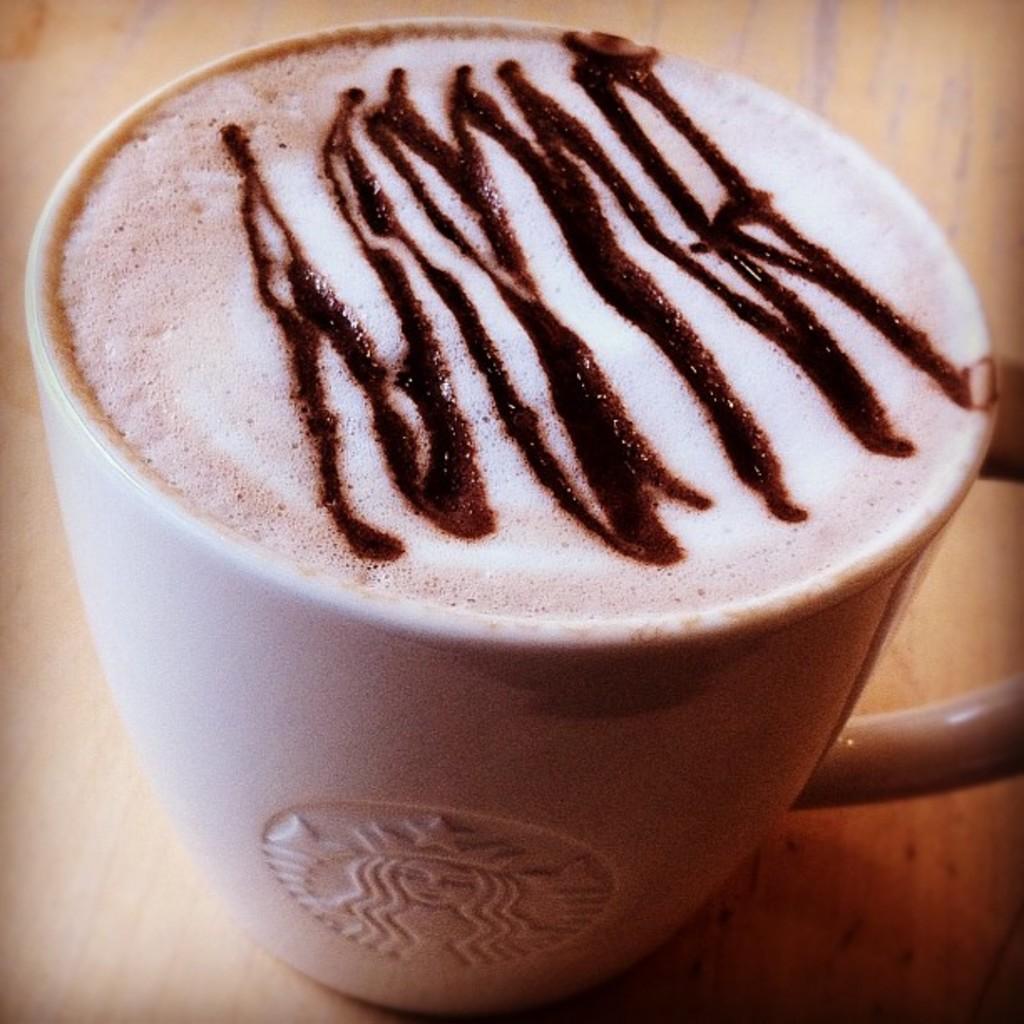Please provide a concise description of this image. In this image there is coffee in a mug on a table. 